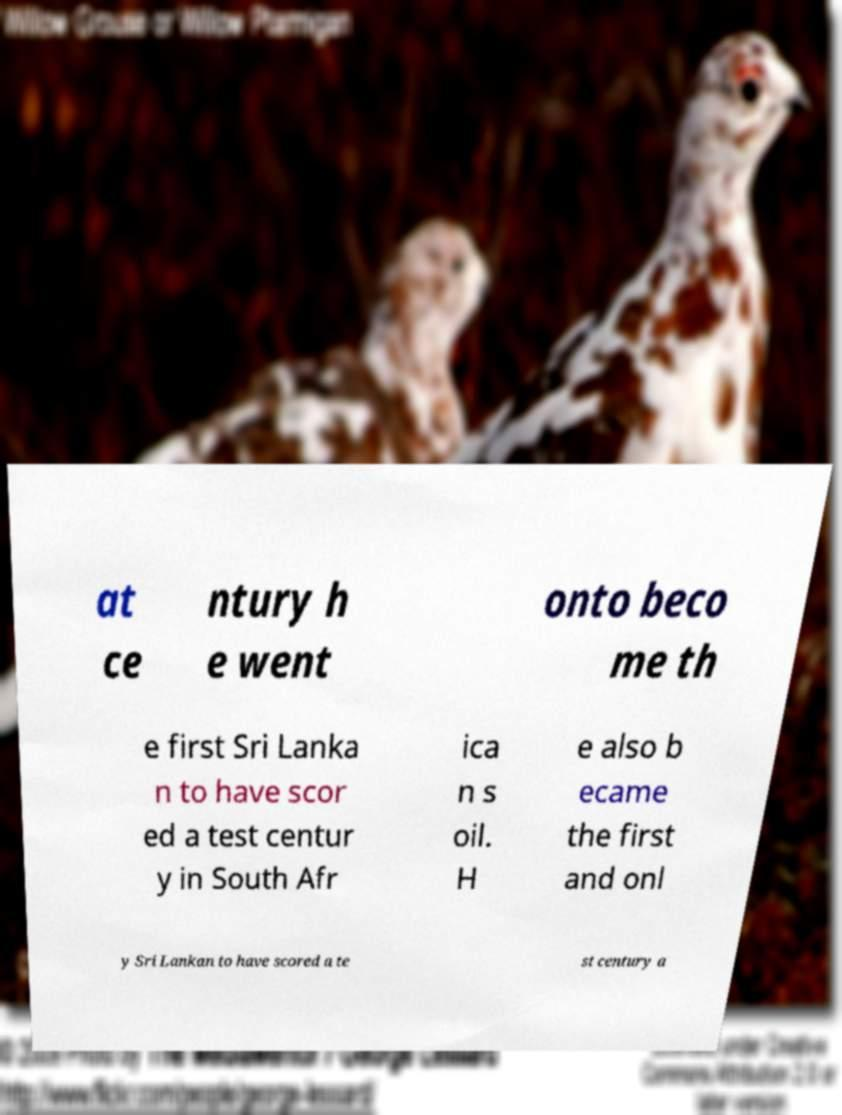Please read and relay the text visible in this image. What does it say? at ce ntury h e went onto beco me th e first Sri Lanka n to have scor ed a test centur y in South Afr ica n s oil. H e also b ecame the first and onl y Sri Lankan to have scored a te st century a 